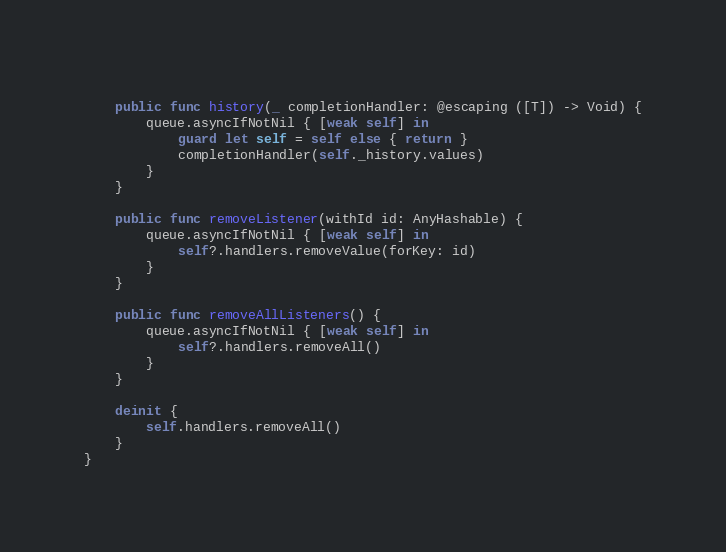<code> <loc_0><loc_0><loc_500><loc_500><_Swift_>	
	public func history(_ completionHandler: @escaping ([T]) -> Void) {
		queue.asyncIfNotNil { [weak self] in
			guard let self = self else { return }
			completionHandler(self._history.values)
		}
	}
	
	public func removeListener(withId id: AnyHashable) {
		queue.asyncIfNotNil { [weak self] in
			self?.handlers.removeValue(forKey: id)
		}
	}
	
	public func removeAllListeners() {
		queue.asyncIfNotNil { [weak self] in
			self?.handlers.removeAll()
		}
	}
	
	deinit {
		self.handlers.removeAll()
	}
}
</code> 